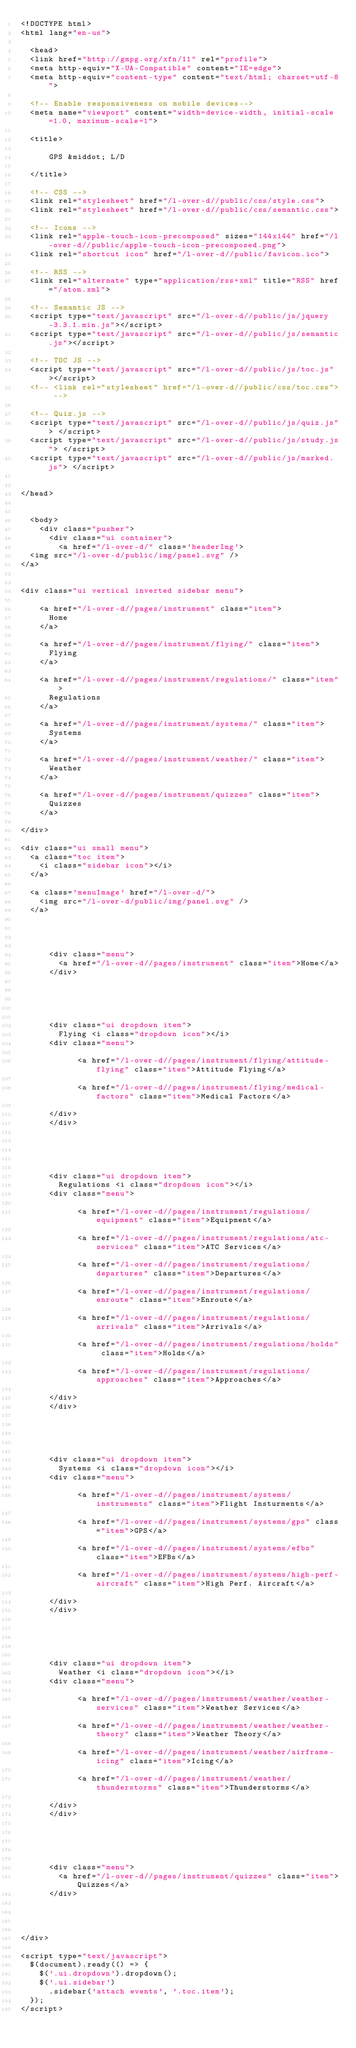<code> <loc_0><loc_0><loc_500><loc_500><_HTML_><!DOCTYPE html>
<html lang="en-us">

  <head>
  <link href="http://gmpg.org/xfn/11" rel="profile">
  <meta http-equiv="X-UA-Compatible" content="IE=edge">
  <meta http-equiv="content-type" content="text/html; charset=utf-8">

  <!-- Enable responsiveness on mobile devices-->
  <meta name="viewport" content="width=device-width, initial-scale=1.0, maximum-scale=1">

  <title>
    
      GPS &middot; L/D
    
  </title>

  <!-- CSS -->  
  <link rel="stylesheet" href="/l-over-d//public/css/style.css">
  <link rel="stylesheet" href="/l-over-d//public/css/semantic.css">

  <!-- Icons -->
  <link rel="apple-touch-icon-precomposed" sizes="144x144" href="/l-over-d//public/apple-touch-icon-precomposed.png">
  <link rel="shortcut icon" href="/l-over-d//public/favicon.ico">

  <!-- RSS -->
  <link rel="alternate" type="application/rss+xml" title="RSS" href="/atom.xml">

  <!-- Semantic JS -->
  <script type="text/javascript" src="/l-over-d//public/js/jquery-3.3.1.min.js"></script>
  <script type="text/javascript" src="/l-over-d//public/js/semantic.js"></script>

  <!-- TOC JS -->
  <script type="text/javascript" src="/l-over-d//public/js/toc.js"></script>
  <!-- <link rel="stylesheet" href="/l-over-d//public/css/toc.css"> -->

  <!-- Quiz.js -->
  <script type="text/javascript" src="/l-over-d//public/js/quiz.js"> </script>
  <script type="text/javascript" src="/l-over-d//public/js/study.js"> </script>
  <script type="text/javascript" src="/l-over-d//public/js/marked.js"> </script>


</head>


  <body>
    <div class="pusher">
      <div class="ui container">
        <a href="/l-over-d/" class='headerImg'>
	<img src="/l-over-d/public/img/panel.svg" />
</a>


<div class="ui vertical inverted sidebar menu">
	
		<a href="/l-over-d//pages/instrument" class="item">
			Home
		</a>
	
		<a href="/l-over-d//pages/instrument/flying/" class="item">
			Flying
		</a>
	
		<a href="/l-over-d//pages/instrument/regulations/" class="item">
			Regulations
		</a>
	
		<a href="/l-over-d//pages/instrument/systems/" class="item">
			Systems
		</a>
	
		<a href="/l-over-d//pages/instrument/weather/" class="item">
			Weather
		</a>
	
		<a href="/l-over-d//pages/instrument/quizzes" class="item">
			Quizzes
		</a>
	
</div>

<div class="ui small menu">
	<a class="toc item">
	  <i class="sidebar icon"></i>
	</a>

	<a class='menuImage' href="/l-over-d/">
		<img src="/l-over-d/public/img/panel.svg" />
	</a>

	

		
			<div class="menu">
				<a href="/l-over-d//pages/instrument" class="item">Home</a>
			</div>
		

	

		
			<div class="ui dropdown item">
				Flying <i class="dropdown icon"></i>
			<div class="menu">
				
		    		<a href="/l-over-d//pages/instrument/flying/attitude-flying" class="item">Attitude Flying</a>
			
		    		<a href="/l-over-d//pages/instrument/flying/medical-factors" class="item">Medical Factors</a>
			
			</div>
			</div>
		

	

		
			<div class="ui dropdown item">
				Regulations <i class="dropdown icon"></i>
			<div class="menu">
				
		    		<a href="/l-over-d//pages/instrument/regulations/equipment" class="item">Equipment</a>
			
		    		<a href="/l-over-d//pages/instrument/regulations/atc-services" class="item">ATC Services</a>
			
		    		<a href="/l-over-d//pages/instrument/regulations/departures" class="item">Departures</a>
			
		    		<a href="/l-over-d//pages/instrument/regulations/enroute" class="item">Enroute</a>
			
		    		<a href="/l-over-d//pages/instrument/regulations/arrivals" class="item">Arrivals</a>
			
		    		<a href="/l-over-d//pages/instrument/regulations/holds" class="item">Holds</a>
			
		    		<a href="/l-over-d//pages/instrument/regulations/approaches" class="item">Approaches</a>
			
			</div>
			</div>
		

	

		
			<div class="ui dropdown item">
				Systems <i class="dropdown icon"></i>
			<div class="menu">
				
		    		<a href="/l-over-d//pages/instrument/systems/instruments" class="item">Flight Insturments</a>
			
		    		<a href="/l-over-d//pages/instrument/systems/gps" class="item">GPS</a>
			
		    		<a href="/l-over-d//pages/instrument/systems/efbs" class="item">EFBs</a>
			
		    		<a href="/l-over-d//pages/instrument/systems/high-perf-aircraft" class="item">High Perf. Aircraft</a>
			
			</div>
			</div>
		

	

		
			<div class="ui dropdown item">
				Weather <i class="dropdown icon"></i>
			<div class="menu">
				
		    		<a href="/l-over-d//pages/instrument/weather/weather-services" class="item">Weather Services</a>
			
		    		<a href="/l-over-d//pages/instrument/weather/weather-theory" class="item">Weather Theory</a>
			
		    		<a href="/l-over-d//pages/instrument/weather/airframe-icing" class="item">Icing</a>
			
		    		<a href="/l-over-d//pages/instrument/weather/thunderstorms" class="item">Thunderstorms</a>
			
			</div>
			</div>
		

	

		
			<div class="menu">
				<a href="/l-over-d//pages/instrument/quizzes" class="item">Quizzes</a>
			</div>
		

	

</div>

<script type="text/javascript">
	$(document).ready(() => {
		$('.ui.dropdown').dropdown();
		$('.ui.sidebar')
			.sidebar('attach events', '.toc.item');
	});
</script>
</code> 